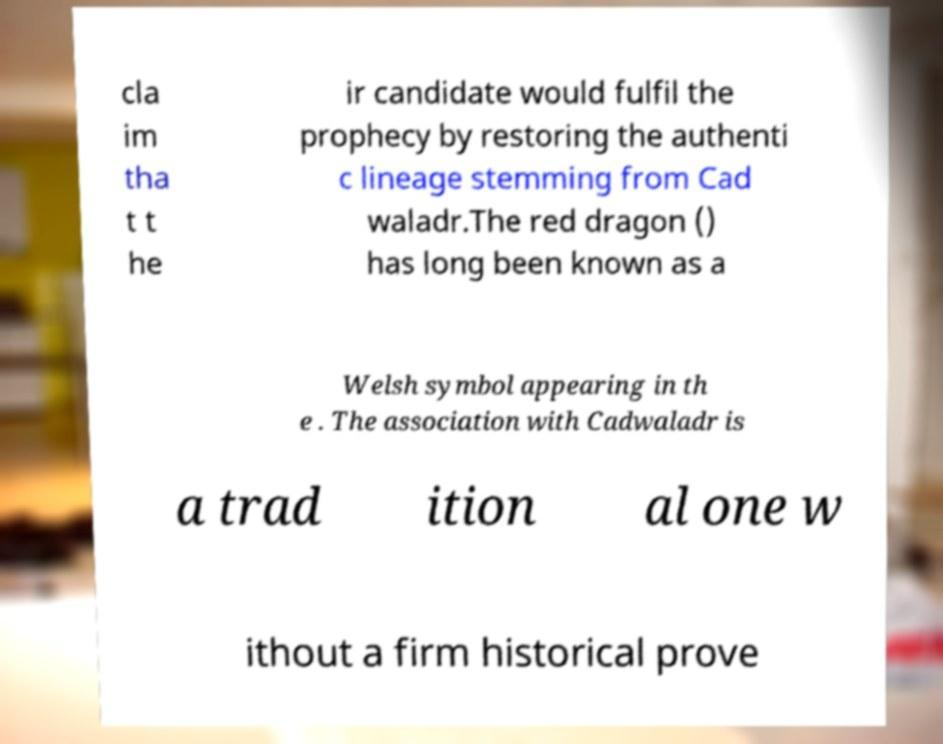Could you extract and type out the text from this image? cla im tha t t he ir candidate would fulfil the prophecy by restoring the authenti c lineage stemming from Cad waladr.The red dragon () has long been known as a Welsh symbol appearing in th e . The association with Cadwaladr is a trad ition al one w ithout a firm historical prove 